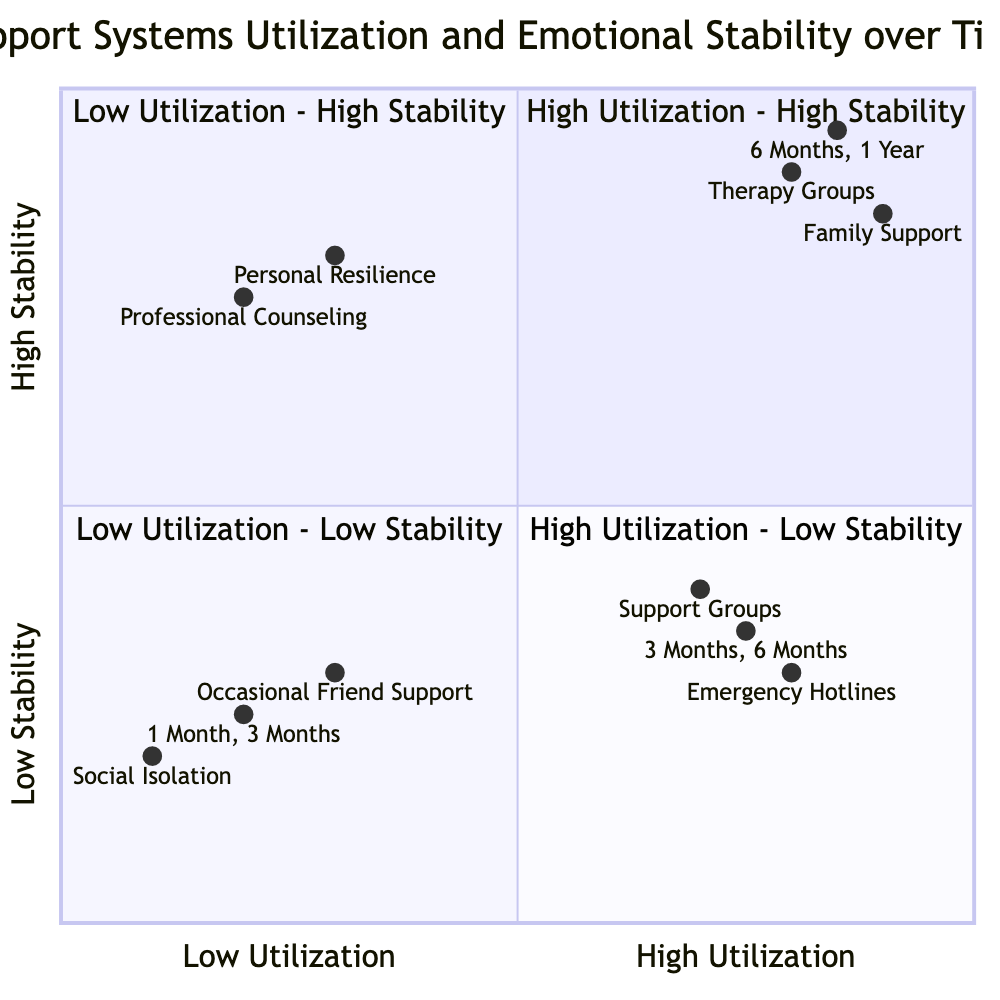What support system is associated with High Utilization - High Stability? The quadrant labeled "High Utilization - High Stability" contains support systems like Therapy Groups and Family Support. These were mentioned in the quadrant's examples.
Answer: Therapy Groups, Family Support In which quadrant would you find Emergency Hotlines? Emergency Hotlines are categorized in the quadrant labeled "High Utilization - Low Stability," as it is listed in the examples for that quadrant.
Answer: High Utilization - Low Stability What time periods are indicated for Low Utilization - Low Stability? The quadrant labeled "Low Utilization - Low Stability" specifies the time periods as 1 Month and 3 Months, which are directly listed in that quadrant's details.
Answer: 1 Month, 3 Months How many support systems are listed in the High Utilization - High Stability quadrant? There are two support systems mentioned in the "High Utilization - High Stability" quadrant: Therapy Groups and Family Support. Hence, the total count is two.
Answer: 2 What is the emotional stability score range for Support Groups? The emotional stability score for Support Groups, as indicated in the diagram, is 0.4, which is its corresponding y-axis value in the High Utilization - Low Stability quadrant.
Answer: 0.4 Which support system corresponds to Low Utilization - High Stability? The quadrant labeled "Low Utilization - High Stability" identifies Personal Resilience and Professional Counseling as the relevant support systems in that category.
Answer: Personal Resilience, Professional Counseling Which time period has the highest emotional stability in the High Utilization - High Stability quadrant? The emotional stability values for both time periods listed in the High Utilization - High Stability quadrant are 0.85 and 0.95, with 0.95 being the highest among them.
Answer: 0.95 What is the relationship between utilization and stability for Support Groups? Support Groups are represented in the "High Utilization - Low Stability" quadrant, indicating that they are frequently used but lead to low emotional stability outcomes, showcasing a negative relationship.
Answer: High Utilization, Low Stability How many quadrants show Low Utilization? There are two quadrants that demonstrate Low Utilization: "Low Utilization - High Stability" and "Low Utilization - Low Stability," totaling to two quadrants.
Answer: 2 